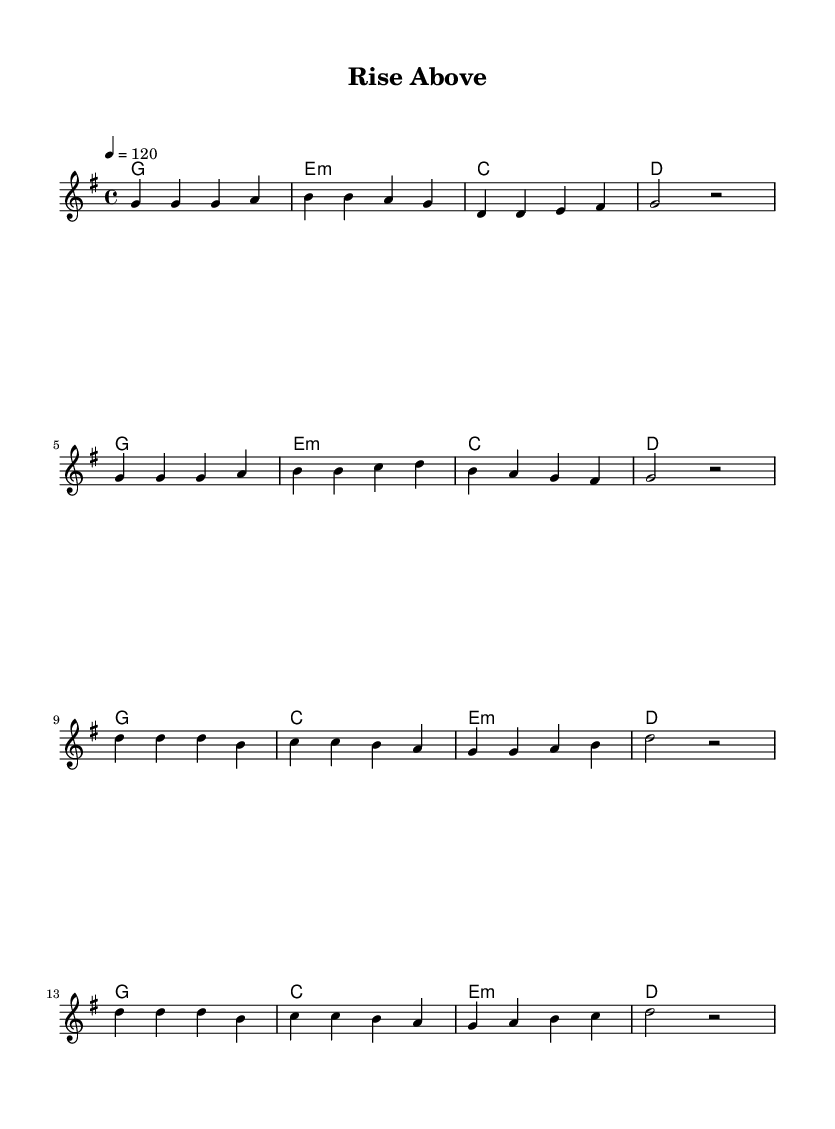What is the key signature of this music? The key signature is G major, which has one sharp (F#).
Answer: G major What is the time signature of this piece? The time signature is 4/4, indicating that there are four beats in each measure.
Answer: 4/4 What is the tempo marking for this piece? The tempo marking is 120 beats per minute, which means it should be played at a moderate speed.
Answer: 120 How many measures are in the verse section? The verse section consists of 8 measures, as shown in the notation.
Answer: 8 What is the main theme reflected in the lyrics? The main theme in the lyrics is overcoming challenges, as expressed through phrases emphasizing strength and resilience.
Answer: Overcoming challenges What is the chord progression used in the verse? The chord progression in the verse is G, E minor, C, D, indicating a common pop structure emphasizing uplifting feelings.
Answer: G, Em, C, D What is the first note of the chorus? The first note of the chorus is D, which starts the melodic line and highlights the empowering message.
Answer: D 